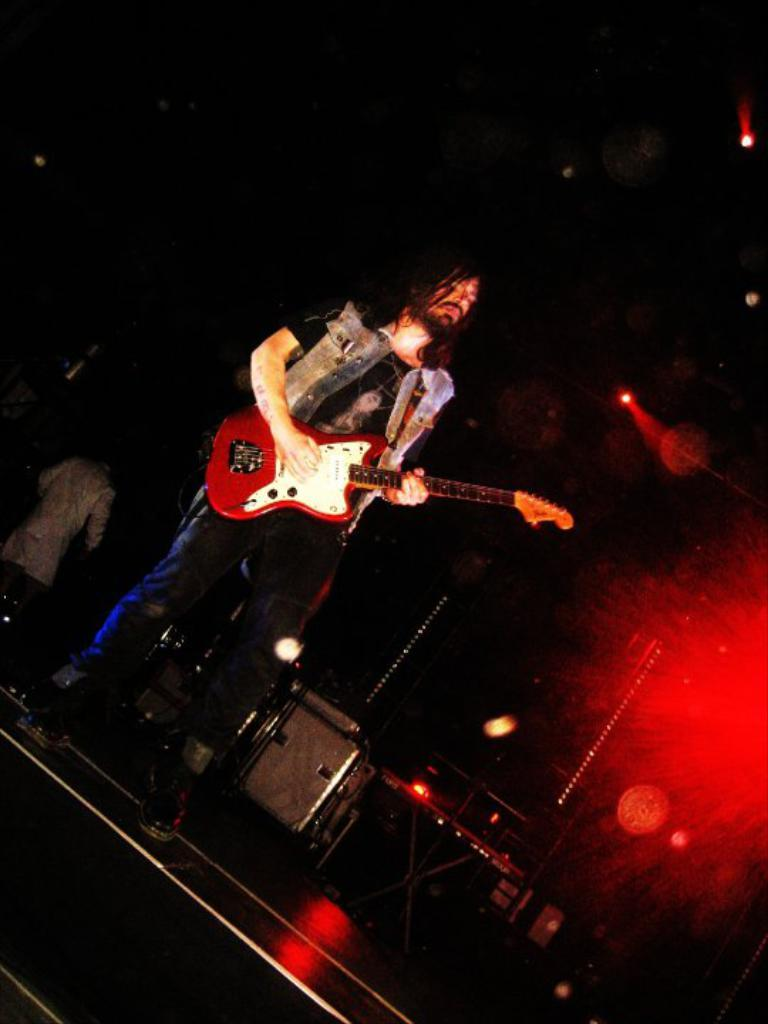What is the man in the image doing? The man is playing a guitar in the image. Where is the man playing the guitar? The man is on a stage. What objects are visible behind the man? There are boxes and a piano behind the man. Are there any other people in the image? Yes, there is another man in the left corner of the image. What type of hat is the man wearing while reciting a verse in the image? There is no man reciting a verse in the image, nor is there any hat present. 